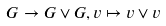<formula> <loc_0><loc_0><loc_500><loc_500>G \to G \vee G , v \mapsto v \vee v</formula> 